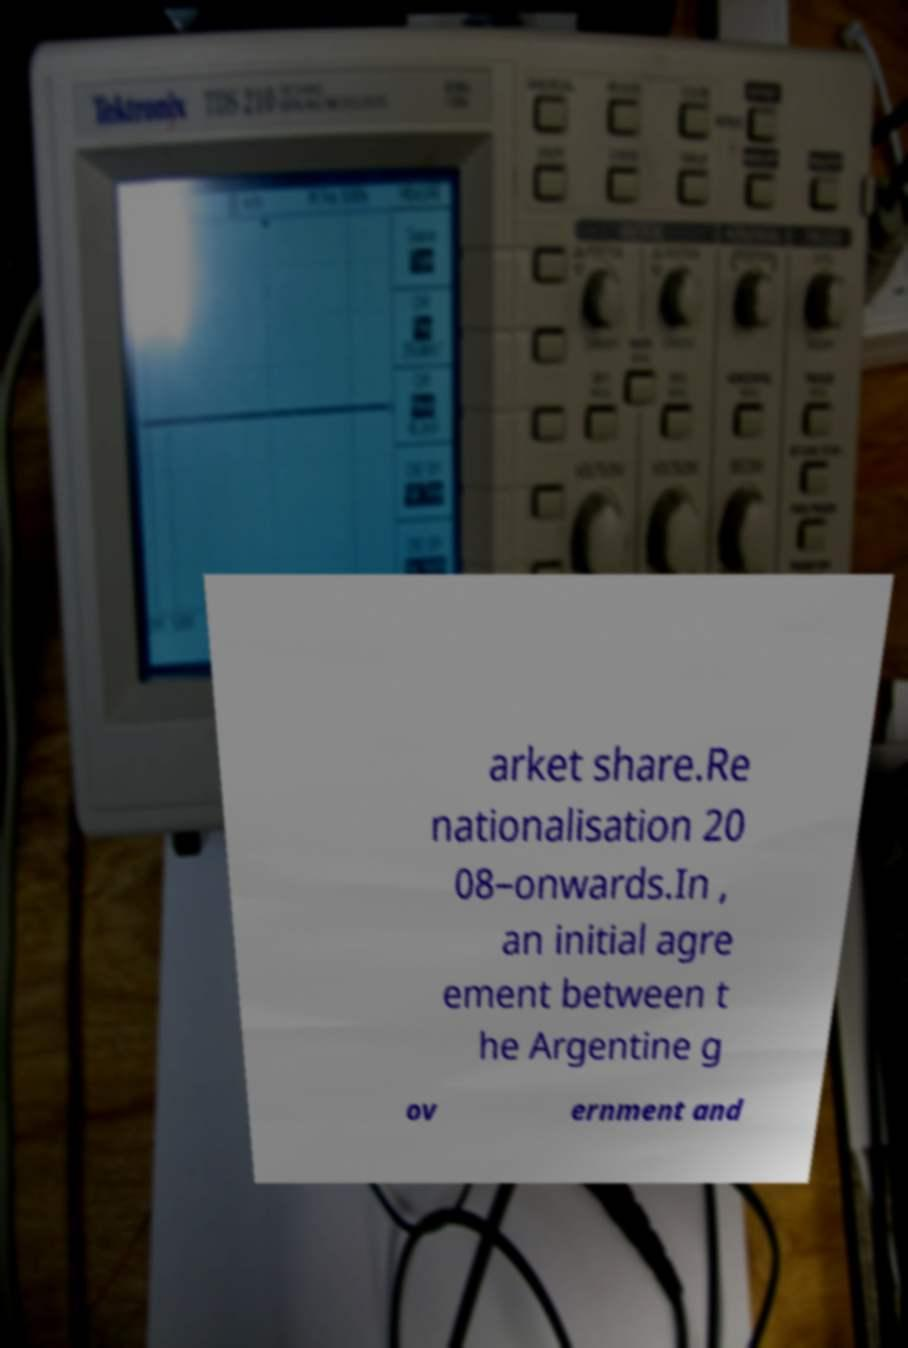Could you extract and type out the text from this image? arket share.Re nationalisation 20 08–onwards.In , an initial agre ement between t he Argentine g ov ernment and 